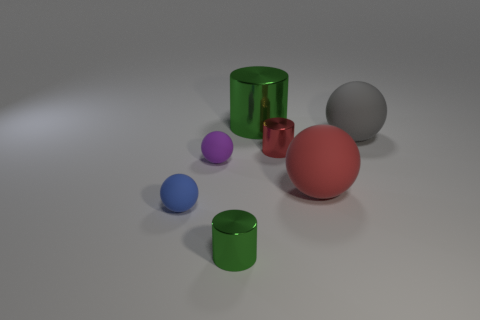Subtract 1 cylinders. How many cylinders are left? 2 Subtract all green balls. Subtract all brown cylinders. How many balls are left? 4 Add 1 cylinders. How many objects exist? 8 Subtract all cylinders. How many objects are left? 4 Subtract all tiny cyan metallic cylinders. Subtract all gray objects. How many objects are left? 6 Add 7 gray things. How many gray things are left? 8 Add 2 small gray balls. How many small gray balls exist? 2 Subtract 1 red balls. How many objects are left? 6 